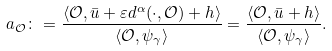Convert formula to latex. <formula><loc_0><loc_0><loc_500><loc_500>a _ { \mathcal { O } } & \colon = \frac { \left \langle \mathcal { O } , \bar { u } + \varepsilon d ^ { \alpha } ( \cdot , \mathcal { O } ) + h \right \rangle } { \left \langle \mathcal { O } , \psi _ { \gamma } \right \rangle } = \frac { \left \langle \mathcal { O } , \bar { u } + h \right \rangle } { \left \langle \mathcal { O } , \psi _ { \gamma } \right \rangle } .</formula> 